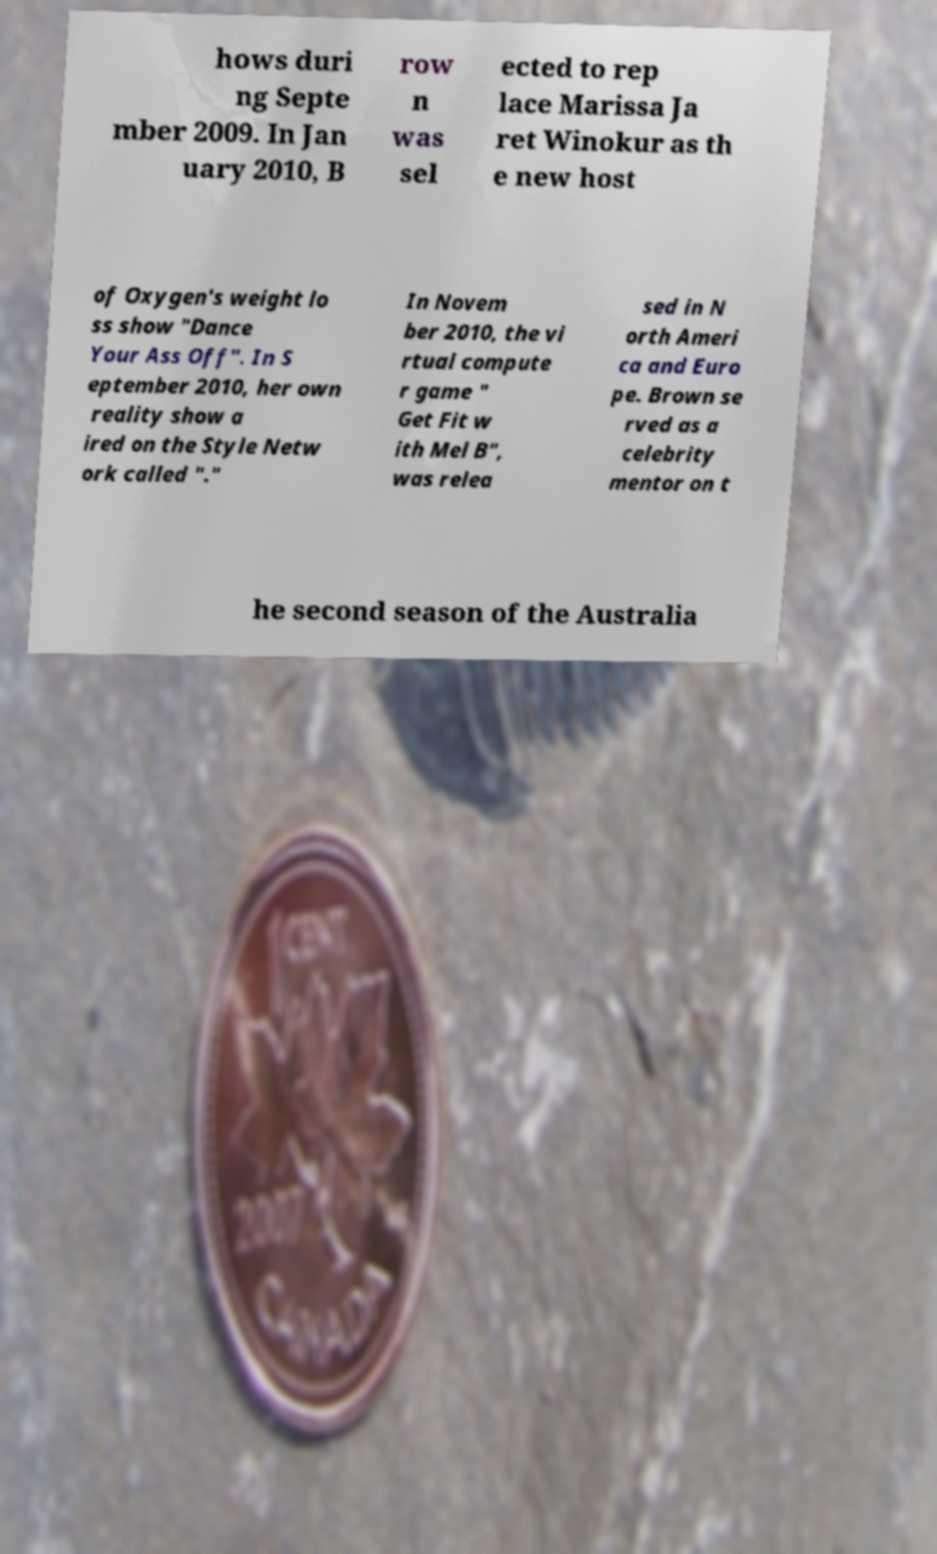I need the written content from this picture converted into text. Can you do that? hows duri ng Septe mber 2009. In Jan uary 2010, B row n was sel ected to rep lace Marissa Ja ret Winokur as th e new host of Oxygen's weight lo ss show "Dance Your Ass Off". In S eptember 2010, her own reality show a ired on the Style Netw ork called "." In Novem ber 2010, the vi rtual compute r game " Get Fit w ith Mel B", was relea sed in N orth Ameri ca and Euro pe. Brown se rved as a celebrity mentor on t he second season of the Australia 